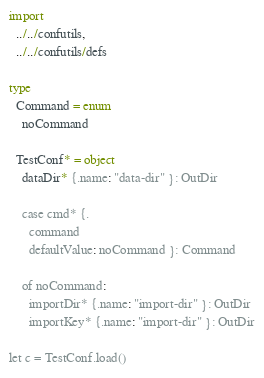<code> <loc_0><loc_0><loc_500><loc_500><_Nim_>import 
  ../../confutils, 
  ../../confutils/defs
  
type
  Command = enum
    noCommand
    
  TestConf* = object
    dataDir* {.name: "data-dir" }: OutDir    
    
    case cmd* {.
      command
      defaultValue: noCommand }: Command

    of noCommand:
      importDir* {.name: "import-dir" }: OutDir
      importKey* {.name: "import-dir" }: OutDir

let c = TestConf.load()
</code> 